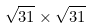<formula> <loc_0><loc_0><loc_500><loc_500>\sqrt { 3 1 } \times \sqrt { 3 1 }</formula> 